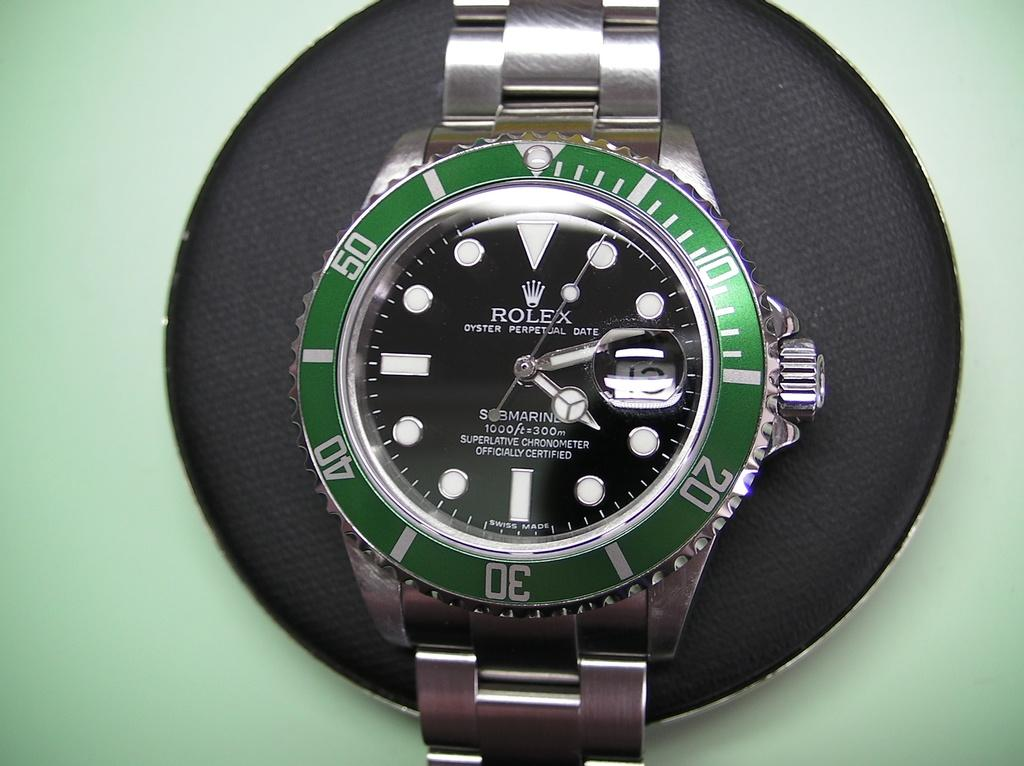<image>
Summarize the visual content of the image. A green Rolex watch sits on a black object on a green table 